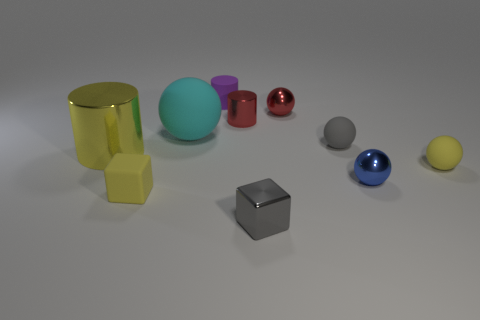How many small gray spheres have the same material as the big sphere?
Ensure brevity in your answer.  1. What number of matte things are the same size as the yellow cylinder?
Offer a terse response. 1. What material is the tiny yellow object that is left of the small shiny sphere in front of the tiny yellow matte object to the right of the small gray shiny cube made of?
Your response must be concise. Rubber. What number of things are either small spheres or purple cylinders?
Provide a short and direct response. 5. Is there any other thing that has the same material as the yellow cylinder?
Offer a very short reply. Yes. The large yellow metal object is what shape?
Your answer should be very brief. Cylinder. There is a tiny red thing behind the small cylinder in front of the tiny matte cylinder; what is its shape?
Make the answer very short. Sphere. Do the big object left of the matte block and the cyan object have the same material?
Keep it short and to the point. No. How many gray things are either small rubber cubes or large spheres?
Offer a terse response. 0. Is there a large cylinder of the same color as the large rubber sphere?
Keep it short and to the point. No. 